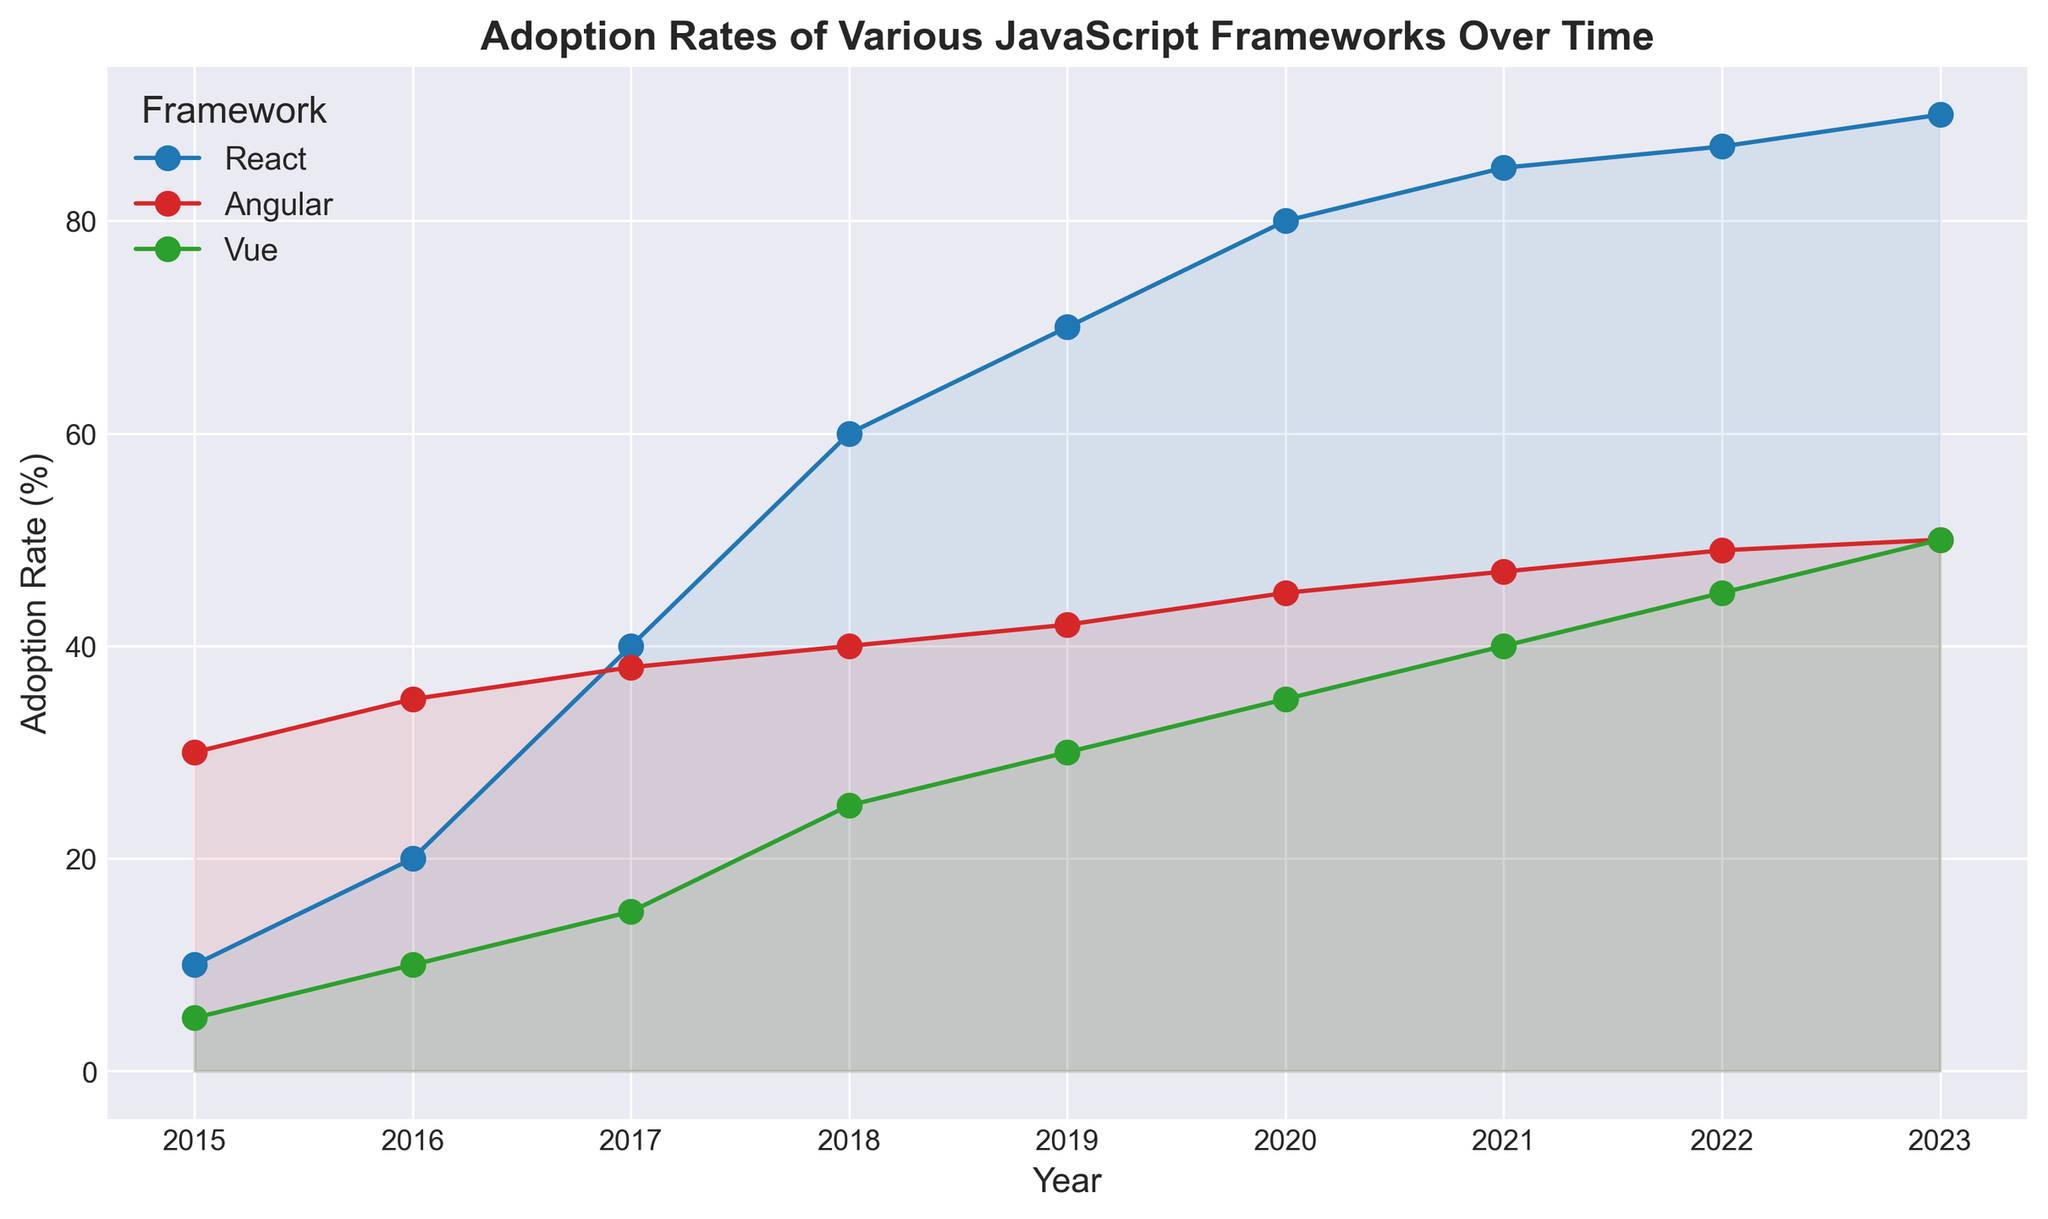What framework had the highest adoption rate in 2015? In the plot, check the data points for the year 2015. Compare the heights of the lines. The highest point in 2015 belongs to Angular.
Answer: Angular What is the rate of adoption increase for React between 2016 and 2020? For React, find the adoption rates for 2016 and 2020 from the respective points. React had an adoption rate of 20 in 2016 and 80 in 2020, so the increase is 80 - 20 = 60.
Answer: 60 Which framework had the slowest growth in adoption rate between 2015 and 2023? Calculate the difference in adoption rates for each framework from 2015 to 2023. React's difference is 90 - 10 = 80, Angular's difference is 50 - 30 = 20, and Vue's difference is 50 - 5 = 45. Angular had the slowest growth.
Answer: Angular Between which two consecutive years did Vue see the highest increase in adoption rate? Look for the largest vertical gap between consecutive years for Vue. The highest increase appears from 2017 (15) to 2018 (25), which is 10.
Answer: Between 2017 and 2018 How does the adoption rate for React in 2018 compare to that for Vue in 2020? Find the adoption rate for React in 2018 (60) and Vue in 2020 (35) from the respective data points. React's adoption rate is higher than Vue's.
Answer: React's rate is higher What is the average adoption rate of Angular from 2015 to 2023? Sum the adoption rates of Angular from 2015 to 2023 and divide by the number of years. The sum is 30+35+38+40+42+45+47+49+50 = 376. There are 9 years, so the average is 376 / 9 ≈ 41.78.
Answer: 41.78 In which year did React surpass Angular in adoption rate? Compare the lines for React and Angular and find the first intersection point. React surpasses Angular between 2016 and 2017.
Answer: Between 2016 and 2017 What is the visual difference between the lines for React and Vue in 2023? Observe the lengths of the vertical lines for the year 2023. React's line is longer (90) compared to Vue's line (50).
Answer: React's line is longer Which framework had the most consistent (least fluctuating) growth? Compare the smoothness and steadiness of the lines. Angular's line appears the most straight and consistent without significant jumps, indicating the least fluctuation.
Answer: Angular What is the combined adoption rate of all three frameworks in 2019? Add the adoption rates for all three frameworks in 2019. React is 70, Angular is 42, and Vue is 30. So, 70 + 42 + 30 = 142.
Answer: 142 